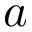<formula> <loc_0><loc_0><loc_500><loc_500>a</formula> 